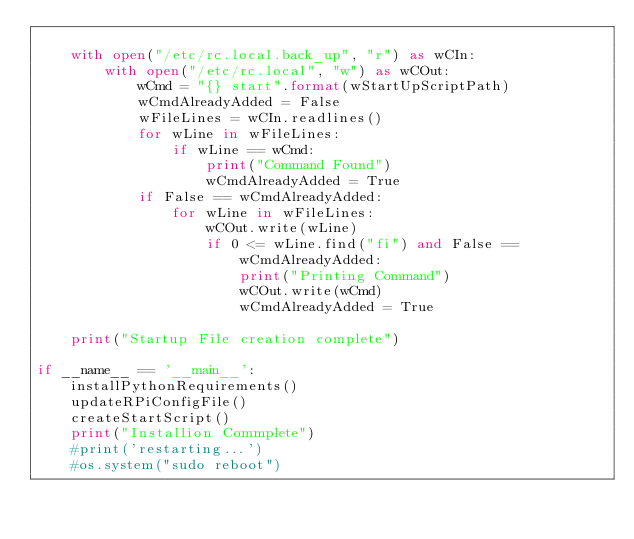<code> <loc_0><loc_0><loc_500><loc_500><_Python_>
    with open("/etc/rc.local.back_up", "r") as wCIn:
        with open("/etc/rc.local", "w") as wCOut:
            wCmd = "{} start".format(wStartUpScriptPath)
            wCmdAlreadyAdded = False
            wFileLines = wCIn.readlines()
            for wLine in wFileLines:
                if wLine == wCmd:
                    print("Command Found")
                    wCmdAlreadyAdded = True
            if False == wCmdAlreadyAdded:
                for wLine in wFileLines:
                    wCOut.write(wLine)
                    if 0 <= wLine.find("fi") and False == wCmdAlreadyAdded:
                        print("Printing Command")
                        wCOut.write(wCmd)
                        wCmdAlreadyAdded = True
                
    print("Startup File creation complete")

if __name__ == '__main__':
    installPythonRequirements()
    updateRPiConfigFile()
    createStartScript()
    print("Installion Commplete")
    #print('restarting...')
    #os.system("sudo reboot")
</code> 